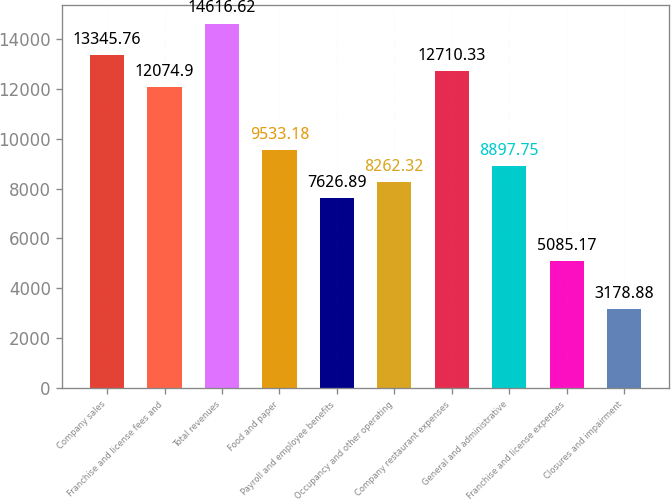<chart> <loc_0><loc_0><loc_500><loc_500><bar_chart><fcel>Company sales<fcel>Franchise and license fees and<fcel>Total revenues<fcel>Food and paper<fcel>Payroll and employee benefits<fcel>Occupancy and other operating<fcel>Company restaurant expenses<fcel>General and administrative<fcel>Franchise and license expenses<fcel>Closures and impairment<nl><fcel>13345.8<fcel>12074.9<fcel>14616.6<fcel>9533.18<fcel>7626.89<fcel>8262.32<fcel>12710.3<fcel>8897.75<fcel>5085.17<fcel>3178.88<nl></chart> 